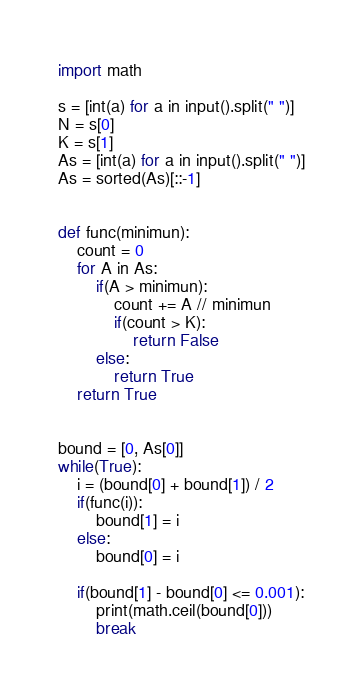<code> <loc_0><loc_0><loc_500><loc_500><_Python_>import math

s = [int(a) for a in input().split(" ")]
N = s[0]
K = s[1]
As = [int(a) for a in input().split(" ")]
As = sorted(As)[::-1]


def func(minimun):
    count = 0
    for A in As:
        if(A > minimun):
            count += A // minimun
            if(count > K):
                return False
        else:
            return True
    return True


bound = [0, As[0]]
while(True):
    i = (bound[0] + bound[1]) / 2
    if(func(i)):
        bound[1] = i
    else:
        bound[0] = i

    if(bound[1] - bound[0] <= 0.001):
        print(math.ceil(bound[0]))
        break
</code> 